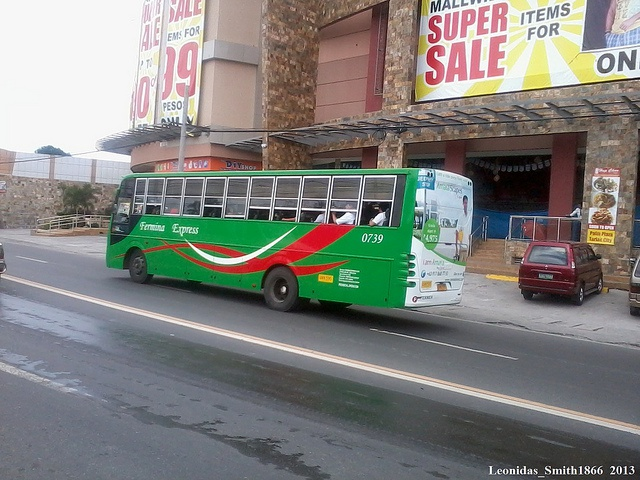Describe the objects in this image and their specific colors. I can see bus in white, gray, green, black, and lightgray tones, car in white, maroon, black, gray, and brown tones, car in white, gray, black, and darkgray tones, people in white, gray, darkgray, and black tones, and people in white, black, lavender, gray, and darkgray tones in this image. 